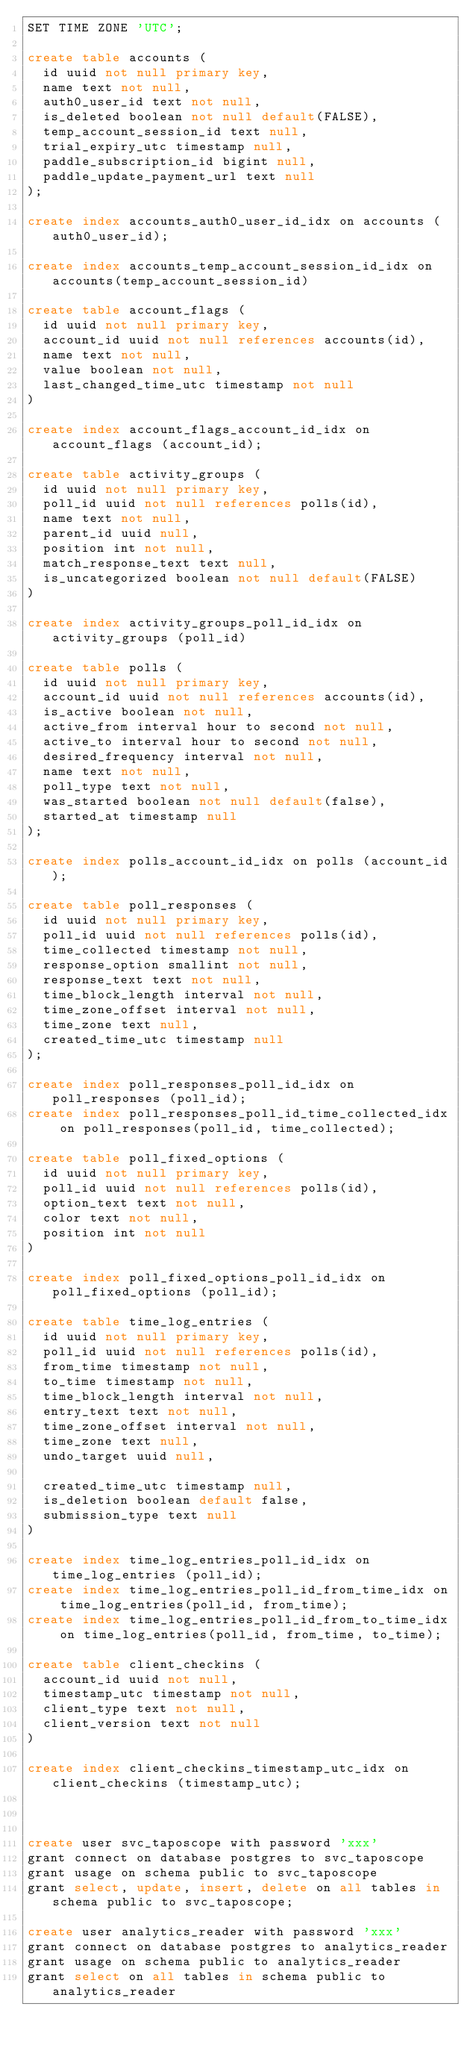Convert code to text. <code><loc_0><loc_0><loc_500><loc_500><_SQL_>SET TIME ZONE 'UTC';

create table accounts (
	id uuid not null primary key,
	name text not null,
	auth0_user_id text not null,
	is_deleted boolean not null default(FALSE),
	temp_account_session_id text null,
	trial_expiry_utc timestamp null,
	paddle_subscription_id bigint null,
	paddle_update_payment_url text null
);

create index accounts_auth0_user_id_idx on accounts (auth0_user_id);

create index accounts_temp_account_session_id_idx on accounts(temp_account_session_id)

create table account_flags (
	id uuid not null primary key,
	account_id uuid not null references accounts(id),
	name text not null,
	value boolean not null,
	last_changed_time_utc timestamp not null
)

create index account_flags_account_id_idx on account_flags (account_id);

create table activity_groups (
	id uuid not null primary key,
	poll_id uuid not null references polls(id),
	name text not null,
	parent_id uuid null,
	position int not null,
	match_response_text text null,
	is_uncategorized boolean not null default(FALSE)
)

create index activity_groups_poll_id_idx on activity_groups (poll_id)

create table polls (
	id uuid not null primary key,
	account_id uuid not null references accounts(id),
	is_active boolean not null,
	active_from interval hour to second not null,
	active_to interval hour to second not null,
	desired_frequency interval not null,
	name text not null,
	poll_type text not null,
	was_started boolean not null default(false),
	started_at timestamp null
);

create index polls_account_id_idx on polls (account_id);

create table poll_responses (
	id uuid not null primary key,
	poll_id uuid not null references polls(id),
	time_collected timestamp not null,
	response_option smallint not null,
	response_text text not null,
	time_block_length interval not null,
	time_zone_offset interval not null,
	time_zone text null,
	created_time_utc timestamp null
);

create index poll_responses_poll_id_idx on poll_responses (poll_id);
create index poll_responses_poll_id_time_collected_idx on poll_responses(poll_id, time_collected);

create table poll_fixed_options (
	id uuid not null primary key,
	poll_id uuid not null references polls(id),
	option_text text not null,
	color text not null,
	position int not null
)

create index poll_fixed_options_poll_id_idx on poll_fixed_options (poll_id);

create table time_log_entries (
	id uuid not null primary key,
	poll_id uuid not null references polls(id),
	from_time timestamp not null,
	to_time timestamp not null,
	time_block_length interval not null,
	entry_text text not null,
	time_zone_offset interval not null,
	time_zone text null,
	undo_target uuid null,
	
	created_time_utc timestamp null,
	is_deletion boolean default false,
	submission_type text null
)

create index time_log_entries_poll_id_idx on time_log_entries (poll_id);
create index time_log_entries_poll_id_from_time_idx on time_log_entries(poll_id, from_time);
create index time_log_entries_poll_id_from_to_time_idx on time_log_entries(poll_id, from_time, to_time);

create table client_checkins (
	account_id uuid not null,
	timestamp_utc timestamp not null,
	client_type text not null,
	client_version text not null
)

create index client_checkins_timestamp_utc_idx on client_checkins (timestamp_utc);



create user svc_taposcope with password 'xxx'
grant connect on database postgres to svc_taposcope
grant usage on schema public to svc_taposcope
grant select, update, insert, delete on all tables in schema public to svc_taposcope;

create user analytics_reader with password 'xxx'
grant connect on database postgres to analytics_reader
grant usage on schema public to analytics_reader
grant select on all tables in schema public to analytics_reader


</code> 